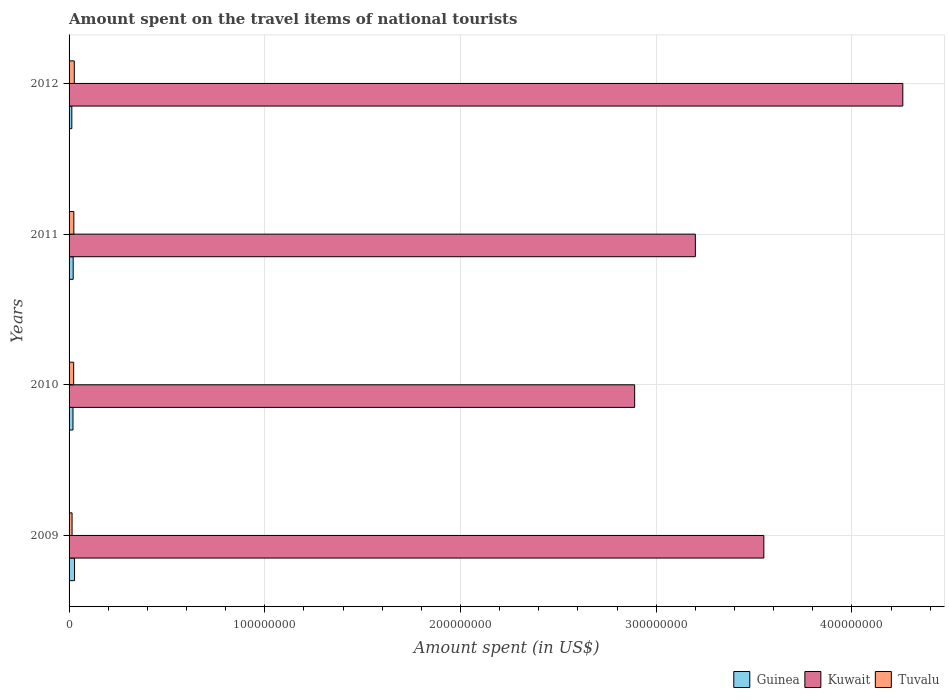Are the number of bars on each tick of the Y-axis equal?
Ensure brevity in your answer.  Yes. How many bars are there on the 3rd tick from the bottom?
Keep it short and to the point. 3. What is the amount spent on the travel items of national tourists in Guinea in 2011?
Ensure brevity in your answer.  2.10e+06. Across all years, what is the maximum amount spent on the travel items of national tourists in Guinea?
Offer a very short reply. 2.80e+06. Across all years, what is the minimum amount spent on the travel items of national tourists in Kuwait?
Your response must be concise. 2.89e+08. In which year was the amount spent on the travel items of national tourists in Tuvalu maximum?
Provide a short and direct response. 2012. What is the total amount spent on the travel items of national tourists in Kuwait in the graph?
Your answer should be compact. 1.39e+09. What is the difference between the amount spent on the travel items of national tourists in Tuvalu in 2009 and that in 2012?
Your answer should be compact. -1.14e+06. What is the difference between the amount spent on the travel items of national tourists in Kuwait in 2010 and the amount spent on the travel items of national tourists in Tuvalu in 2009?
Offer a very short reply. 2.87e+08. What is the average amount spent on the travel items of national tourists in Guinea per year?
Your answer should be compact. 2.08e+06. In the year 2010, what is the difference between the amount spent on the travel items of national tourists in Guinea and amount spent on the travel items of national tourists in Tuvalu?
Offer a very short reply. -3.50e+05. In how many years, is the amount spent on the travel items of national tourists in Kuwait greater than 280000000 US$?
Offer a terse response. 4. What is the ratio of the amount spent on the travel items of national tourists in Tuvalu in 2011 to that in 2012?
Offer a terse response. 0.91. Is the amount spent on the travel items of national tourists in Guinea in 2009 less than that in 2012?
Offer a very short reply. No. What is the difference between the highest and the lowest amount spent on the travel items of national tourists in Guinea?
Provide a short and direct response. 1.39e+06. Is the sum of the amount spent on the travel items of national tourists in Tuvalu in 2010 and 2012 greater than the maximum amount spent on the travel items of national tourists in Kuwait across all years?
Keep it short and to the point. No. What does the 3rd bar from the top in 2012 represents?
Give a very brief answer. Guinea. What does the 2nd bar from the bottom in 2009 represents?
Keep it short and to the point. Kuwait. Is it the case that in every year, the sum of the amount spent on the travel items of national tourists in Kuwait and amount spent on the travel items of national tourists in Guinea is greater than the amount spent on the travel items of national tourists in Tuvalu?
Your answer should be compact. Yes. How many bars are there?
Your answer should be compact. 12. Are all the bars in the graph horizontal?
Your answer should be very brief. Yes. How many years are there in the graph?
Offer a terse response. 4. Are the values on the major ticks of X-axis written in scientific E-notation?
Keep it short and to the point. No. Does the graph contain any zero values?
Offer a terse response. No. Does the graph contain grids?
Your answer should be very brief. Yes. Where does the legend appear in the graph?
Give a very brief answer. Bottom right. How are the legend labels stacked?
Offer a very short reply. Horizontal. What is the title of the graph?
Give a very brief answer. Amount spent on the travel items of national tourists. What is the label or title of the X-axis?
Make the answer very short. Amount spent (in US$). What is the Amount spent (in US$) of Guinea in 2009?
Your answer should be very brief. 2.80e+06. What is the Amount spent (in US$) in Kuwait in 2009?
Your answer should be very brief. 3.55e+08. What is the Amount spent (in US$) of Tuvalu in 2009?
Make the answer very short. 1.53e+06. What is the Amount spent (in US$) of Guinea in 2010?
Your answer should be compact. 2.00e+06. What is the Amount spent (in US$) in Kuwait in 2010?
Your response must be concise. 2.89e+08. What is the Amount spent (in US$) in Tuvalu in 2010?
Your answer should be compact. 2.35e+06. What is the Amount spent (in US$) in Guinea in 2011?
Give a very brief answer. 2.10e+06. What is the Amount spent (in US$) of Kuwait in 2011?
Give a very brief answer. 3.20e+08. What is the Amount spent (in US$) in Tuvalu in 2011?
Your response must be concise. 2.44e+06. What is the Amount spent (in US$) in Guinea in 2012?
Keep it short and to the point. 1.41e+06. What is the Amount spent (in US$) of Kuwait in 2012?
Provide a succinct answer. 4.26e+08. What is the Amount spent (in US$) in Tuvalu in 2012?
Give a very brief answer. 2.67e+06. Across all years, what is the maximum Amount spent (in US$) of Guinea?
Offer a very short reply. 2.80e+06. Across all years, what is the maximum Amount spent (in US$) of Kuwait?
Make the answer very short. 4.26e+08. Across all years, what is the maximum Amount spent (in US$) in Tuvalu?
Keep it short and to the point. 2.67e+06. Across all years, what is the minimum Amount spent (in US$) of Guinea?
Provide a succinct answer. 1.41e+06. Across all years, what is the minimum Amount spent (in US$) of Kuwait?
Provide a short and direct response. 2.89e+08. Across all years, what is the minimum Amount spent (in US$) of Tuvalu?
Provide a succinct answer. 1.53e+06. What is the total Amount spent (in US$) of Guinea in the graph?
Provide a succinct answer. 8.31e+06. What is the total Amount spent (in US$) in Kuwait in the graph?
Your answer should be compact. 1.39e+09. What is the total Amount spent (in US$) of Tuvalu in the graph?
Your response must be concise. 8.99e+06. What is the difference between the Amount spent (in US$) in Kuwait in 2009 and that in 2010?
Your answer should be very brief. 6.60e+07. What is the difference between the Amount spent (in US$) of Tuvalu in 2009 and that in 2010?
Provide a succinct answer. -8.20e+05. What is the difference between the Amount spent (in US$) of Kuwait in 2009 and that in 2011?
Make the answer very short. 3.50e+07. What is the difference between the Amount spent (in US$) in Tuvalu in 2009 and that in 2011?
Your answer should be compact. -9.10e+05. What is the difference between the Amount spent (in US$) of Guinea in 2009 and that in 2012?
Give a very brief answer. 1.39e+06. What is the difference between the Amount spent (in US$) in Kuwait in 2009 and that in 2012?
Your answer should be compact. -7.10e+07. What is the difference between the Amount spent (in US$) of Tuvalu in 2009 and that in 2012?
Give a very brief answer. -1.14e+06. What is the difference between the Amount spent (in US$) in Kuwait in 2010 and that in 2011?
Offer a terse response. -3.10e+07. What is the difference between the Amount spent (in US$) of Tuvalu in 2010 and that in 2011?
Your answer should be compact. -9.00e+04. What is the difference between the Amount spent (in US$) in Guinea in 2010 and that in 2012?
Your answer should be very brief. 5.90e+05. What is the difference between the Amount spent (in US$) in Kuwait in 2010 and that in 2012?
Your answer should be compact. -1.37e+08. What is the difference between the Amount spent (in US$) in Tuvalu in 2010 and that in 2012?
Give a very brief answer. -3.20e+05. What is the difference between the Amount spent (in US$) in Guinea in 2011 and that in 2012?
Make the answer very short. 6.90e+05. What is the difference between the Amount spent (in US$) in Kuwait in 2011 and that in 2012?
Make the answer very short. -1.06e+08. What is the difference between the Amount spent (in US$) of Guinea in 2009 and the Amount spent (in US$) of Kuwait in 2010?
Offer a terse response. -2.86e+08. What is the difference between the Amount spent (in US$) in Guinea in 2009 and the Amount spent (in US$) in Tuvalu in 2010?
Provide a succinct answer. 4.50e+05. What is the difference between the Amount spent (in US$) in Kuwait in 2009 and the Amount spent (in US$) in Tuvalu in 2010?
Offer a terse response. 3.53e+08. What is the difference between the Amount spent (in US$) of Guinea in 2009 and the Amount spent (in US$) of Kuwait in 2011?
Give a very brief answer. -3.17e+08. What is the difference between the Amount spent (in US$) in Kuwait in 2009 and the Amount spent (in US$) in Tuvalu in 2011?
Provide a succinct answer. 3.53e+08. What is the difference between the Amount spent (in US$) in Guinea in 2009 and the Amount spent (in US$) in Kuwait in 2012?
Make the answer very short. -4.23e+08. What is the difference between the Amount spent (in US$) in Kuwait in 2009 and the Amount spent (in US$) in Tuvalu in 2012?
Your response must be concise. 3.52e+08. What is the difference between the Amount spent (in US$) of Guinea in 2010 and the Amount spent (in US$) of Kuwait in 2011?
Ensure brevity in your answer.  -3.18e+08. What is the difference between the Amount spent (in US$) in Guinea in 2010 and the Amount spent (in US$) in Tuvalu in 2011?
Offer a terse response. -4.40e+05. What is the difference between the Amount spent (in US$) of Kuwait in 2010 and the Amount spent (in US$) of Tuvalu in 2011?
Provide a succinct answer. 2.87e+08. What is the difference between the Amount spent (in US$) of Guinea in 2010 and the Amount spent (in US$) of Kuwait in 2012?
Your response must be concise. -4.24e+08. What is the difference between the Amount spent (in US$) in Guinea in 2010 and the Amount spent (in US$) in Tuvalu in 2012?
Provide a short and direct response. -6.70e+05. What is the difference between the Amount spent (in US$) of Kuwait in 2010 and the Amount spent (in US$) of Tuvalu in 2012?
Give a very brief answer. 2.86e+08. What is the difference between the Amount spent (in US$) of Guinea in 2011 and the Amount spent (in US$) of Kuwait in 2012?
Your response must be concise. -4.24e+08. What is the difference between the Amount spent (in US$) in Guinea in 2011 and the Amount spent (in US$) in Tuvalu in 2012?
Provide a short and direct response. -5.70e+05. What is the difference between the Amount spent (in US$) in Kuwait in 2011 and the Amount spent (in US$) in Tuvalu in 2012?
Offer a terse response. 3.17e+08. What is the average Amount spent (in US$) of Guinea per year?
Make the answer very short. 2.08e+06. What is the average Amount spent (in US$) in Kuwait per year?
Offer a terse response. 3.48e+08. What is the average Amount spent (in US$) in Tuvalu per year?
Your answer should be compact. 2.25e+06. In the year 2009, what is the difference between the Amount spent (in US$) in Guinea and Amount spent (in US$) in Kuwait?
Ensure brevity in your answer.  -3.52e+08. In the year 2009, what is the difference between the Amount spent (in US$) in Guinea and Amount spent (in US$) in Tuvalu?
Provide a short and direct response. 1.27e+06. In the year 2009, what is the difference between the Amount spent (in US$) in Kuwait and Amount spent (in US$) in Tuvalu?
Your response must be concise. 3.53e+08. In the year 2010, what is the difference between the Amount spent (in US$) of Guinea and Amount spent (in US$) of Kuwait?
Make the answer very short. -2.87e+08. In the year 2010, what is the difference between the Amount spent (in US$) of Guinea and Amount spent (in US$) of Tuvalu?
Offer a terse response. -3.50e+05. In the year 2010, what is the difference between the Amount spent (in US$) of Kuwait and Amount spent (in US$) of Tuvalu?
Give a very brief answer. 2.87e+08. In the year 2011, what is the difference between the Amount spent (in US$) in Guinea and Amount spent (in US$) in Kuwait?
Your answer should be very brief. -3.18e+08. In the year 2011, what is the difference between the Amount spent (in US$) of Kuwait and Amount spent (in US$) of Tuvalu?
Your response must be concise. 3.18e+08. In the year 2012, what is the difference between the Amount spent (in US$) of Guinea and Amount spent (in US$) of Kuwait?
Keep it short and to the point. -4.25e+08. In the year 2012, what is the difference between the Amount spent (in US$) in Guinea and Amount spent (in US$) in Tuvalu?
Give a very brief answer. -1.26e+06. In the year 2012, what is the difference between the Amount spent (in US$) of Kuwait and Amount spent (in US$) of Tuvalu?
Make the answer very short. 4.23e+08. What is the ratio of the Amount spent (in US$) of Kuwait in 2009 to that in 2010?
Your response must be concise. 1.23. What is the ratio of the Amount spent (in US$) in Tuvalu in 2009 to that in 2010?
Offer a very short reply. 0.65. What is the ratio of the Amount spent (in US$) of Kuwait in 2009 to that in 2011?
Give a very brief answer. 1.11. What is the ratio of the Amount spent (in US$) in Tuvalu in 2009 to that in 2011?
Offer a terse response. 0.63. What is the ratio of the Amount spent (in US$) in Guinea in 2009 to that in 2012?
Your response must be concise. 1.99. What is the ratio of the Amount spent (in US$) in Kuwait in 2009 to that in 2012?
Offer a terse response. 0.83. What is the ratio of the Amount spent (in US$) in Tuvalu in 2009 to that in 2012?
Your response must be concise. 0.57. What is the ratio of the Amount spent (in US$) of Kuwait in 2010 to that in 2011?
Offer a terse response. 0.9. What is the ratio of the Amount spent (in US$) of Tuvalu in 2010 to that in 2011?
Your answer should be very brief. 0.96. What is the ratio of the Amount spent (in US$) in Guinea in 2010 to that in 2012?
Provide a succinct answer. 1.42. What is the ratio of the Amount spent (in US$) of Kuwait in 2010 to that in 2012?
Your answer should be very brief. 0.68. What is the ratio of the Amount spent (in US$) of Tuvalu in 2010 to that in 2012?
Offer a very short reply. 0.88. What is the ratio of the Amount spent (in US$) in Guinea in 2011 to that in 2012?
Keep it short and to the point. 1.49. What is the ratio of the Amount spent (in US$) of Kuwait in 2011 to that in 2012?
Keep it short and to the point. 0.75. What is the ratio of the Amount spent (in US$) of Tuvalu in 2011 to that in 2012?
Provide a succinct answer. 0.91. What is the difference between the highest and the second highest Amount spent (in US$) of Kuwait?
Offer a very short reply. 7.10e+07. What is the difference between the highest and the lowest Amount spent (in US$) in Guinea?
Offer a terse response. 1.39e+06. What is the difference between the highest and the lowest Amount spent (in US$) of Kuwait?
Your answer should be compact. 1.37e+08. What is the difference between the highest and the lowest Amount spent (in US$) of Tuvalu?
Offer a terse response. 1.14e+06. 